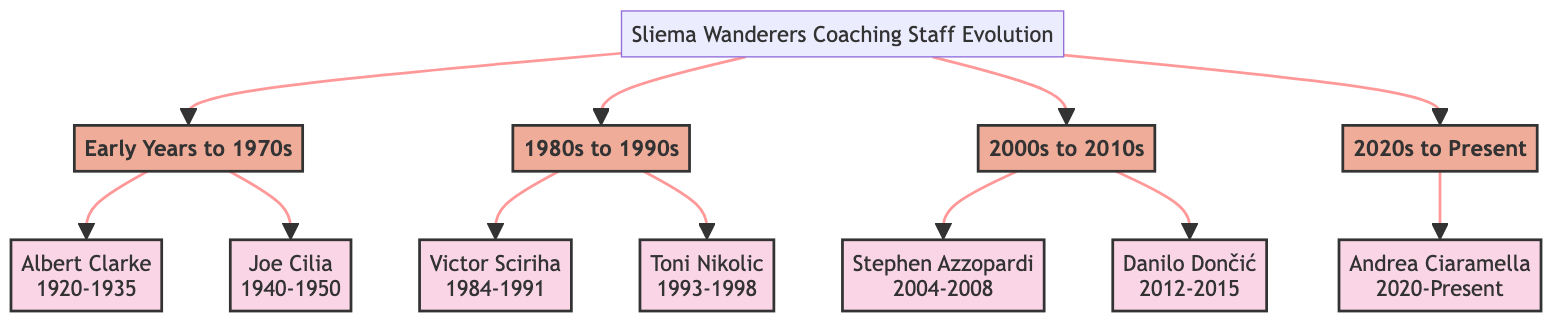What is the first coach listed in the diagram? The first coach listed under "Early Years to 1970s" is Albert Clarke, who had a tenure from 1920 to 1935.
Answer: Albert Clarke How many coaches are represented in the diagram? There are a total of seven coaches listed across different eras in the diagram.
Answer: 7 What tenure did Joe Cilia have as a coach? Joe Cilia's tenure is indicated as 1940-1950 in the diagram.
Answer: 1940-1950 Which coach introduced modern training techniques? Victor Sciriha, who coached from 1984 to 1991, is noted for introducing modern training techniques.
Answer: Victor Sciriha How does Andrea Ciaramella's impact compare to early coaches? Andrea Ciaramella's impact combines tradition with innovation and focuses on consistency, differing from early coaches who laid foundational styles.
Answer: Tradition with innovation Which decade had the coach focused on youth development? The 1990s featured Toni Nikolic, who focused on youth development during his tenure from 1993 to 1998.
Answer: 1990s What is the impact of Stephen Azzopardi listed in the diagram? Stephen Azzopardi is noted for bringing tactical flexibility and adaptability, which led to various cup victories.
Answer: Tactical flexibility and adaptability Who had the longest coaching tenure in the diagram? Albert Clarke had the longest coaching tenure from 1920 to 1935, spanning a total of 15 years.
Answer: Albert Clarke In which decade did Sliema Wanderers start promoting a high-pressing style? The high-pressing style was promoted by Danilo Dončić during his tenure from 2012 to 2015, placing this in the 2010s.
Answer: 2010s 